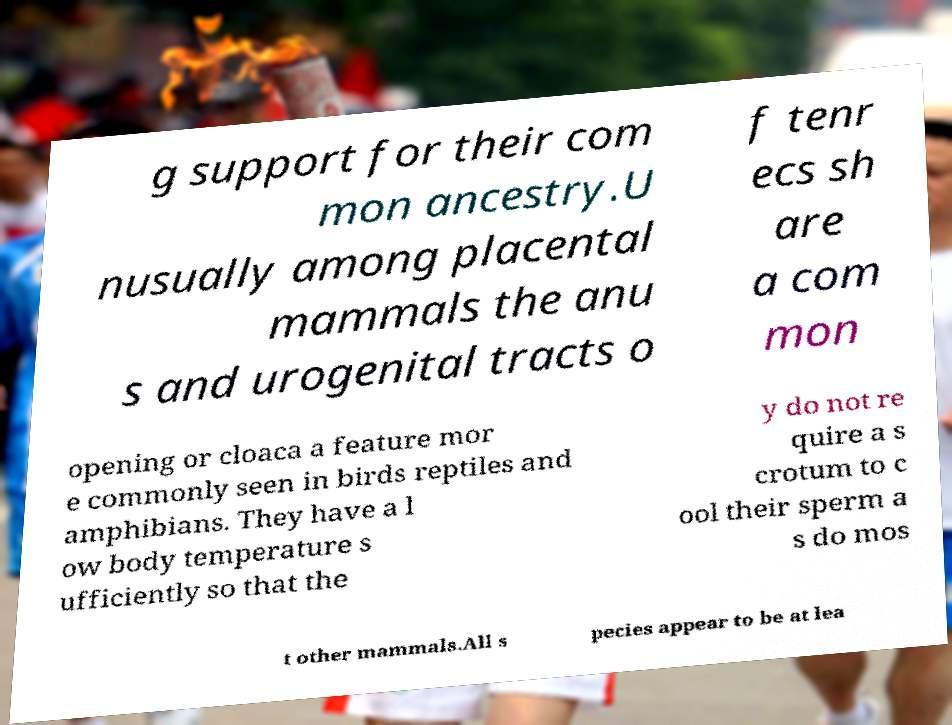Can you accurately transcribe the text from the provided image for me? g support for their com mon ancestry.U nusually among placental mammals the anu s and urogenital tracts o f tenr ecs sh are a com mon opening or cloaca a feature mor e commonly seen in birds reptiles and amphibians. They have a l ow body temperature s ufficiently so that the y do not re quire a s crotum to c ool their sperm a s do mos t other mammals.All s pecies appear to be at lea 